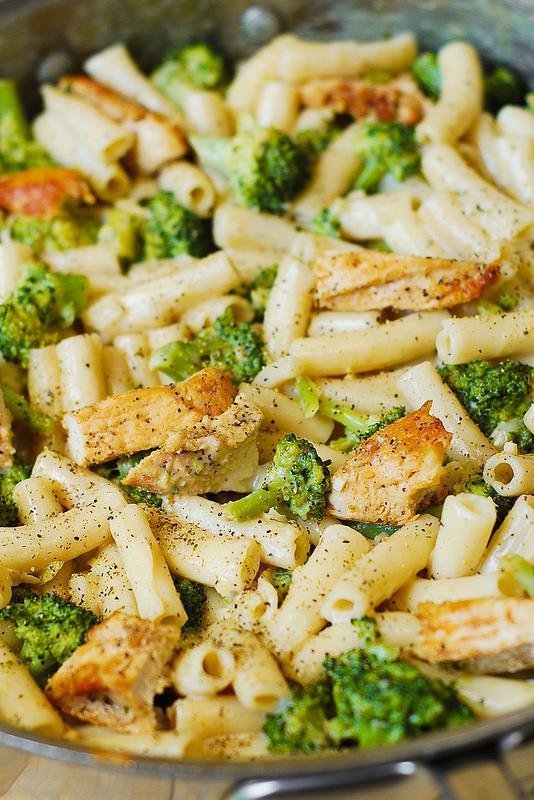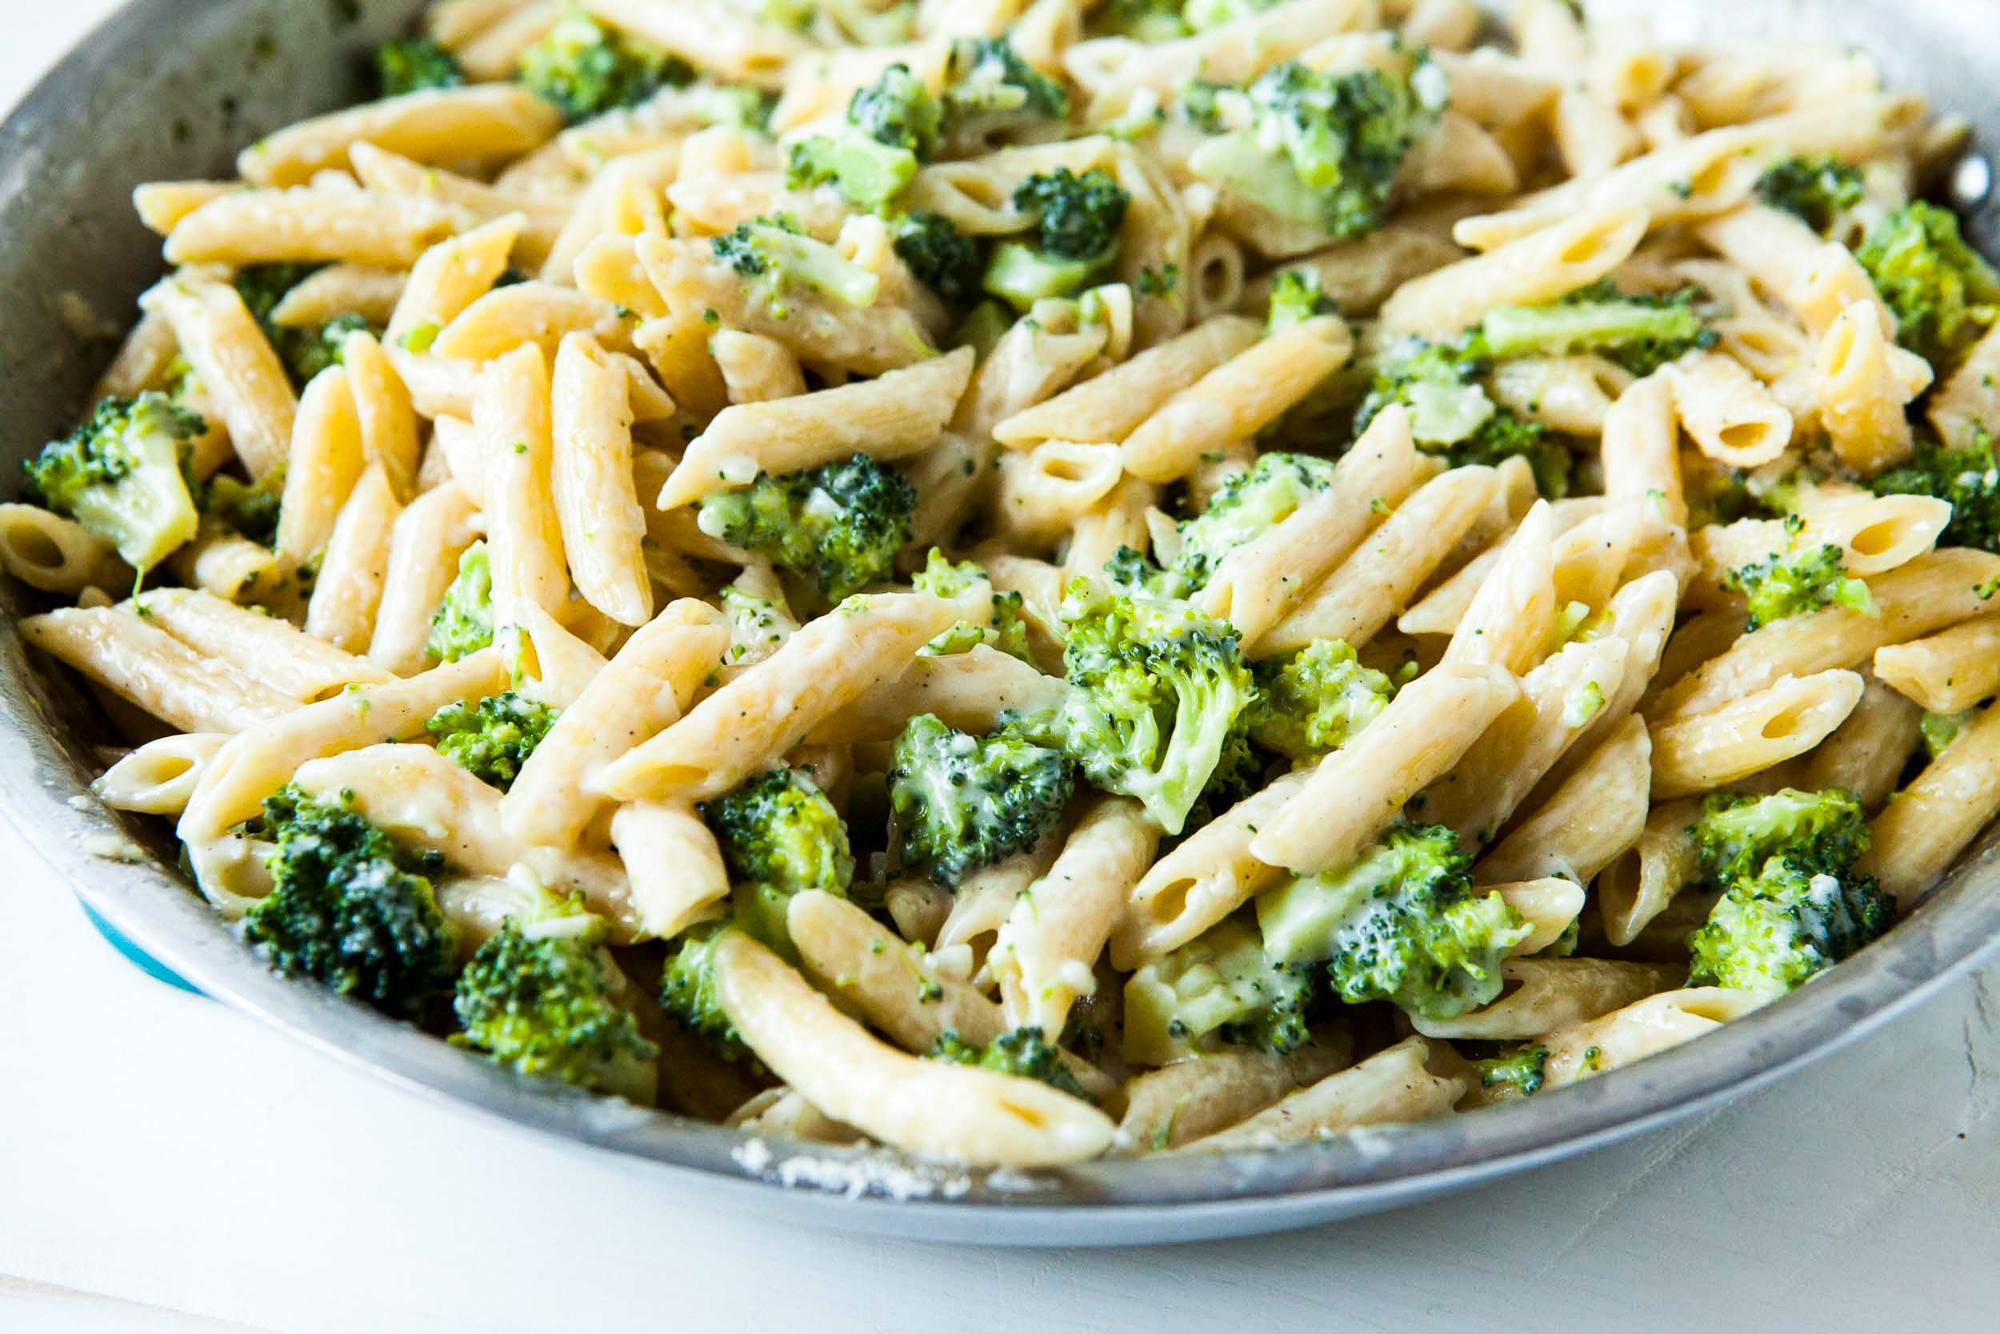The first image is the image on the left, the second image is the image on the right. Evaluate the accuracy of this statement regarding the images: "At least one of the dishes doesn't have penne pasta.". Is it true? Answer yes or no. No. 